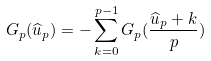Convert formula to latex. <formula><loc_0><loc_0><loc_500><loc_500>G _ { p } ( \widehat { u } _ { p } ) = - \sum _ { k = 0 } ^ { p - 1 } G _ { p } ( \frac { \widehat { u } _ { p } + k } { p } )</formula> 